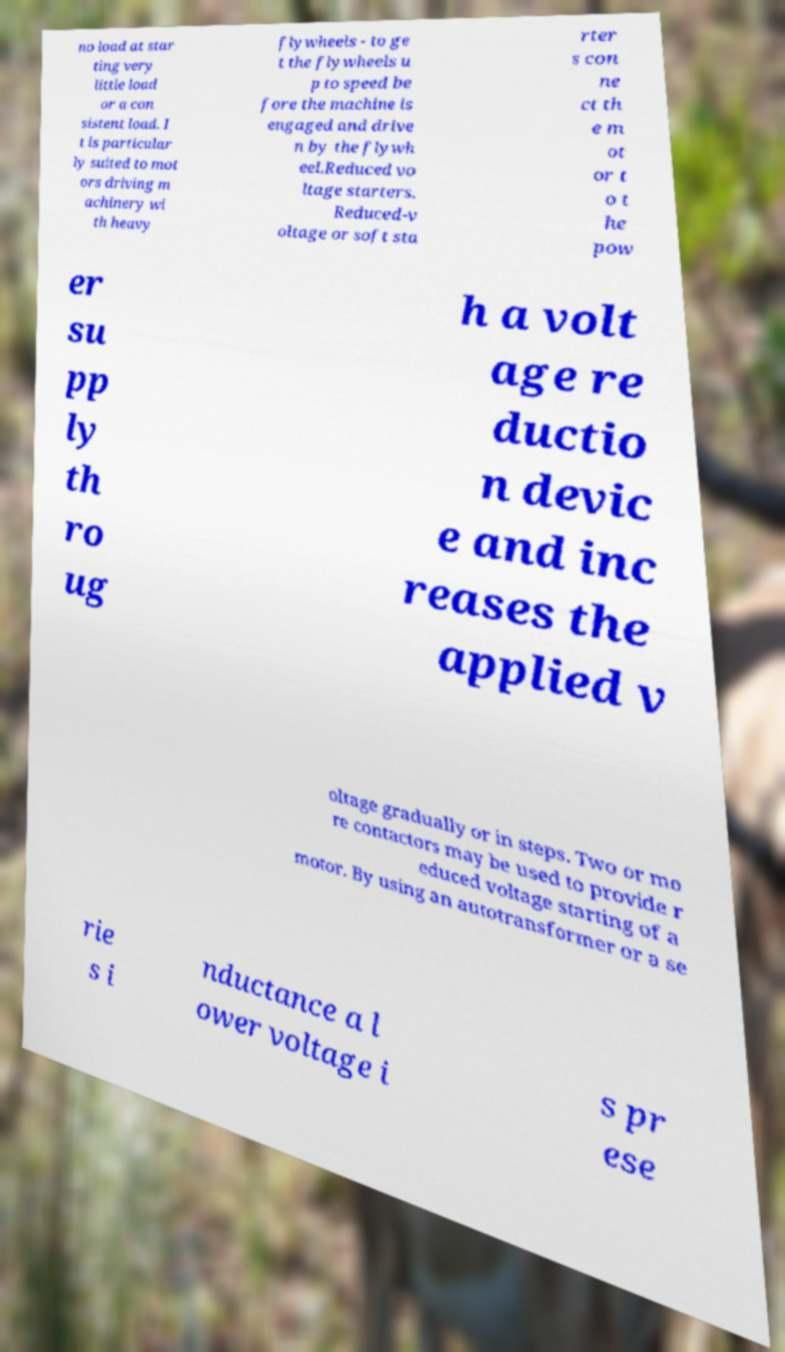Could you extract and type out the text from this image? no load at star ting very little load or a con sistent load. I t is particular ly suited to mot ors driving m achinery wi th heavy flywheels - to ge t the flywheels u p to speed be fore the machine is engaged and drive n by the flywh eel.Reduced vo ltage starters. Reduced-v oltage or soft sta rter s con ne ct th e m ot or t o t he pow er su pp ly th ro ug h a volt age re ductio n devic e and inc reases the applied v oltage gradually or in steps. Two or mo re contactors may be used to provide r educed voltage starting of a motor. By using an autotransformer or a se rie s i nductance a l ower voltage i s pr ese 